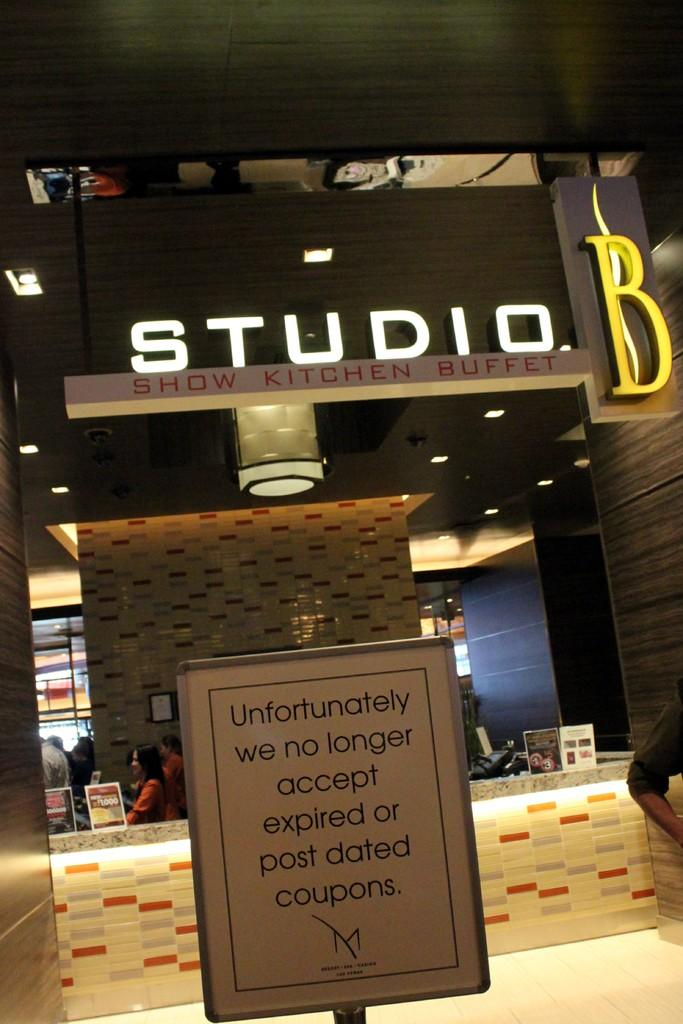What objects are present in the image? There are boards in the image. What can be seen in the background of the image? There is a store and people in the background of the image. What is visible above the boards in the image? There is a ceiling visible in the image. What type of lighting is present in the image? There are lights in the image. Can you describe the presence of a person in the image? The hand of a person is visible on the right side of the image. What appliance is being ordered by the person in the image? A: There is no appliance being ordered in the image, as the focus is on the boards and the hand of a person. 